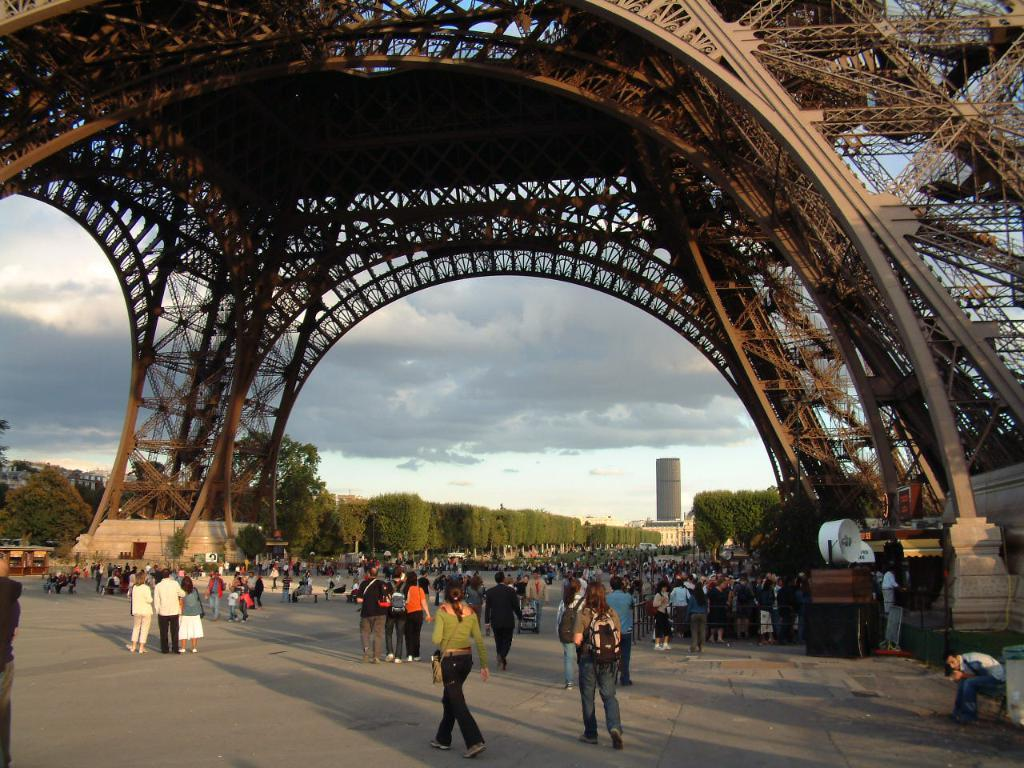What famous landmark can be seen in the picture? There is an Eiffel Tower in the picture. What else can be seen in the picture besides the Eiffel Tower? There are groups of people and objects on the ground visible in the picture. What can be seen in the background of the picture? There are trees, buildings, and a cloudy sky visible in the background of the picture. Can you see any fairies flying around the Eiffel Tower in the picture? There are no fairies visible in the picture. What type of bite can be seen on the Eiffel Tower in the picture? There is no bite visible on the Eiffel Tower in the picture. 